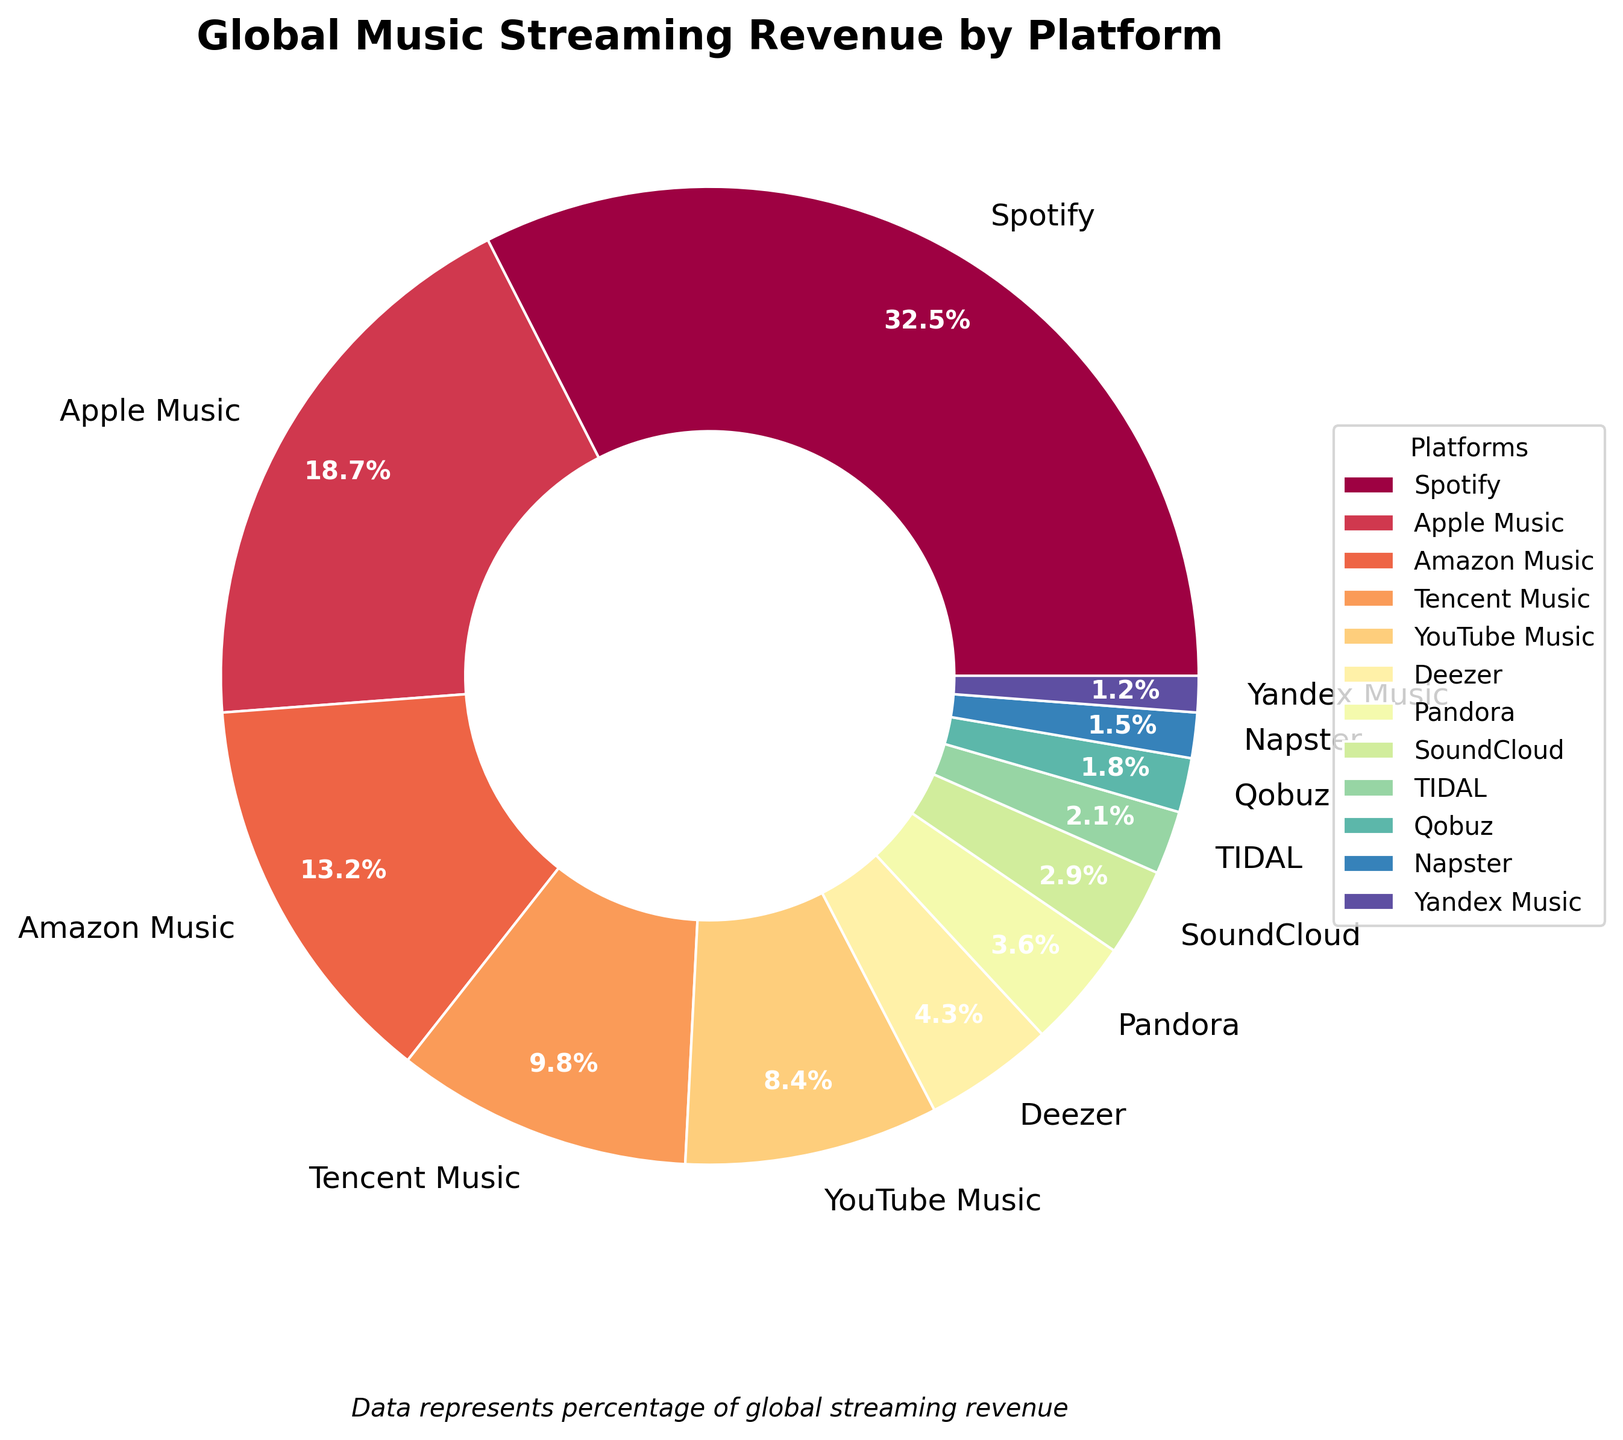Which platform has the highest revenue percentage? The figure shows the breakdown of global music streaming revenue by platform. The platform with the largest portion of the pie chart represents the highest revenue percentage. Spotify occupies the largest part of the chart.
Answer: Spotify How much higher is Spotify's revenue percentage compared to Apple Music? Identify the percentages for Spotify (32.5%) and Apple Music (18.7%) from the chart, and then calculate the difference by subtracting 18.7 from 32.5. 32.5 - 18.7 = 13.8
Answer: 13.8% What's the combined revenue percentage for Amazon Music and Tencent Music? Find the percentages for both Amazon Music (13.2%) and Tencent Music (9.8%) from the chart. Add them together: 13.2 + 9.8 = 23.0
Answer: 23.0% Which platform has the smallest revenue percentage, and what is it? Look for the smallest wedge in the pie chart. The smallest section corresponds to Yandex Music with 1.2%.
Answer: Yandex Music, 1.2% Are YouTube Music and Deezer's combined revenue percentages greater than Apple Music's? First, add the percentages for YouTube Music (8.4%) and Deezer (4.3%). Then, check if their sum (8.4 + 4.3 = 12.7) is greater than Apple Music's percentage (18.7%). 12.7 is not greater than 18.7.
Answer: No Which three platforms contribute the least to the global music streaming revenue combined? Identify the three smallest wedges in the pie chart. These correspond to Yandex Music (1.2%), Napster (1.5%), and Qobuz (1.8%). Sum them: 1.2 + 1.5 + 1.8 = 4.5
Answer: Yandex Music, Napster, Qobuz; 4.5% What's the total revenue percentage for platforms with less than 5% individual revenue? Identify platforms with less than 5%: Deezer (4.3%), Pandora (3.6%), SoundCloud (2.9%), TIDAL (2.1%), Qobuz (1.8%), Napster (1.5%), Yandex Music (1.2%). Add them up: 4.3 + 3.6 + 2.9 + 2.1 + 1.8 + 1.5 + 1.2 = 17.4
Answer: 17.4% Is Amazon Music's revenue percentage closer to Spotify's or Apple Music's? Calculate the two differences: from Amazon Music's 13.2% to Spotify's 32.5% (32.5 - 13.2 = 19.3) and to Apple Music's 18.7% (18.7 - 13.2 = 5.5). Amazon Music's revenue percentage is closer to Apple Music's.
Answer: Apple Music's If TIDAL and SoundCloud both doubled their revenue percentage, what would their new combined percentage be? Double the percentages for TIDAL (2.1%) and SoundCloud (2.9%). TIDAL: 2.1 x 2 = 4.2%; SoundCloud: 2.9 x 2 = 5.8%. Add them: 4.2 + 5.8 = 10.0
Answer: 10.0% 